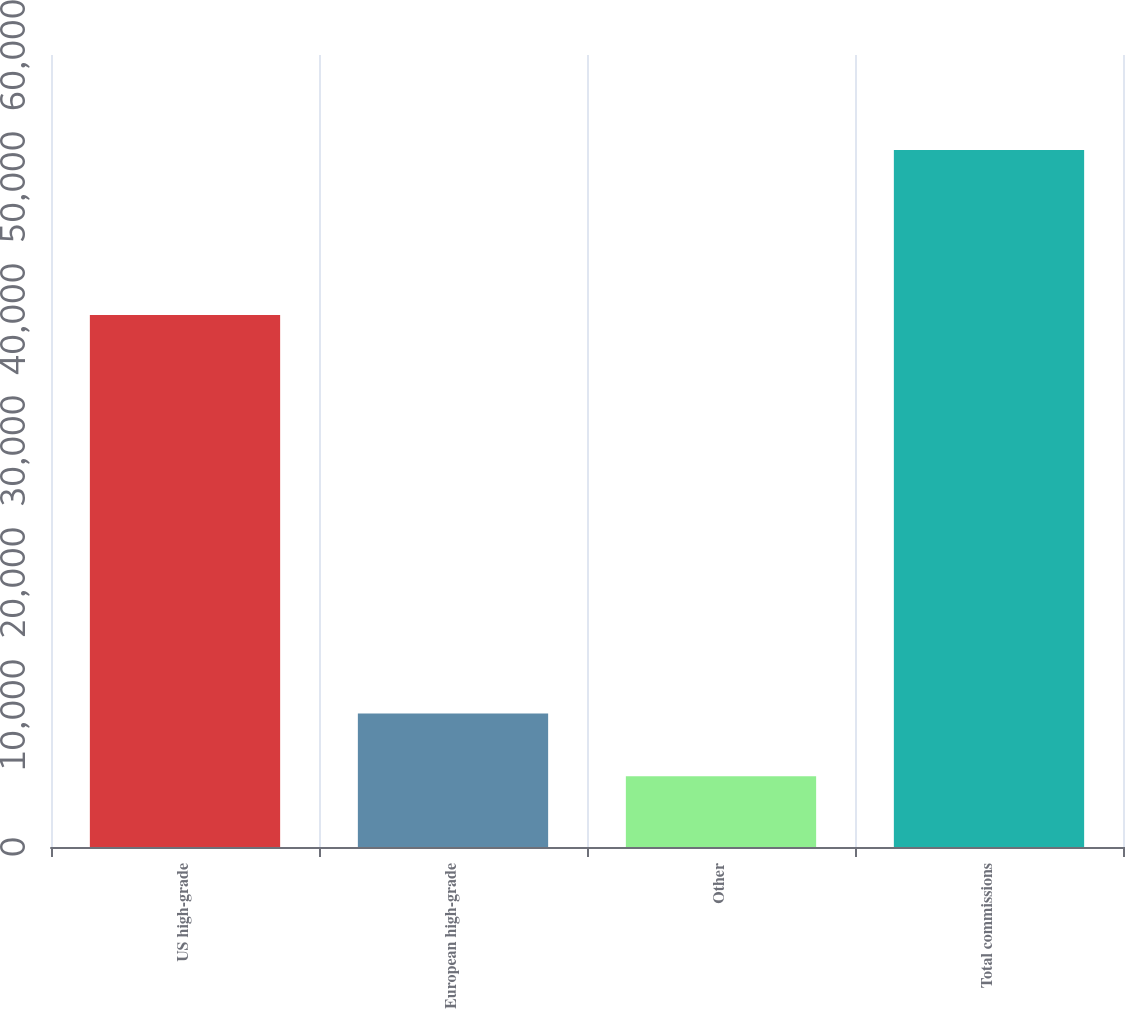Convert chart to OTSL. <chart><loc_0><loc_0><loc_500><loc_500><bar_chart><fcel>US high-grade<fcel>European high-grade<fcel>Other<fcel>Total commissions<nl><fcel>40310<fcel>10107.6<fcel>5364<fcel>52800<nl></chart> 